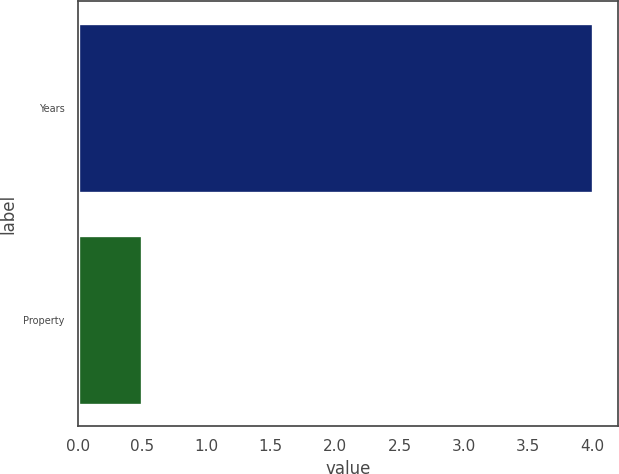Convert chart. <chart><loc_0><loc_0><loc_500><loc_500><bar_chart><fcel>Years<fcel>Property<nl><fcel>4<fcel>0.5<nl></chart> 